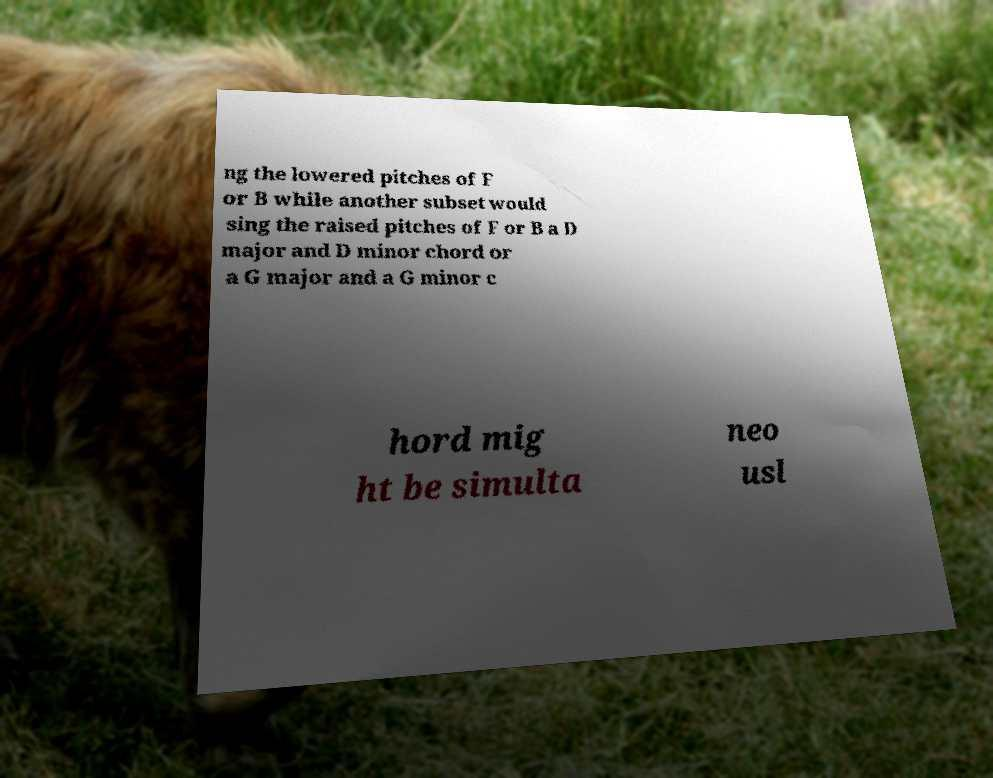Could you extract and type out the text from this image? ng the lowered pitches of F or B while another subset would sing the raised pitches of F or B a D major and D minor chord or a G major and a G minor c hord mig ht be simulta neo usl 